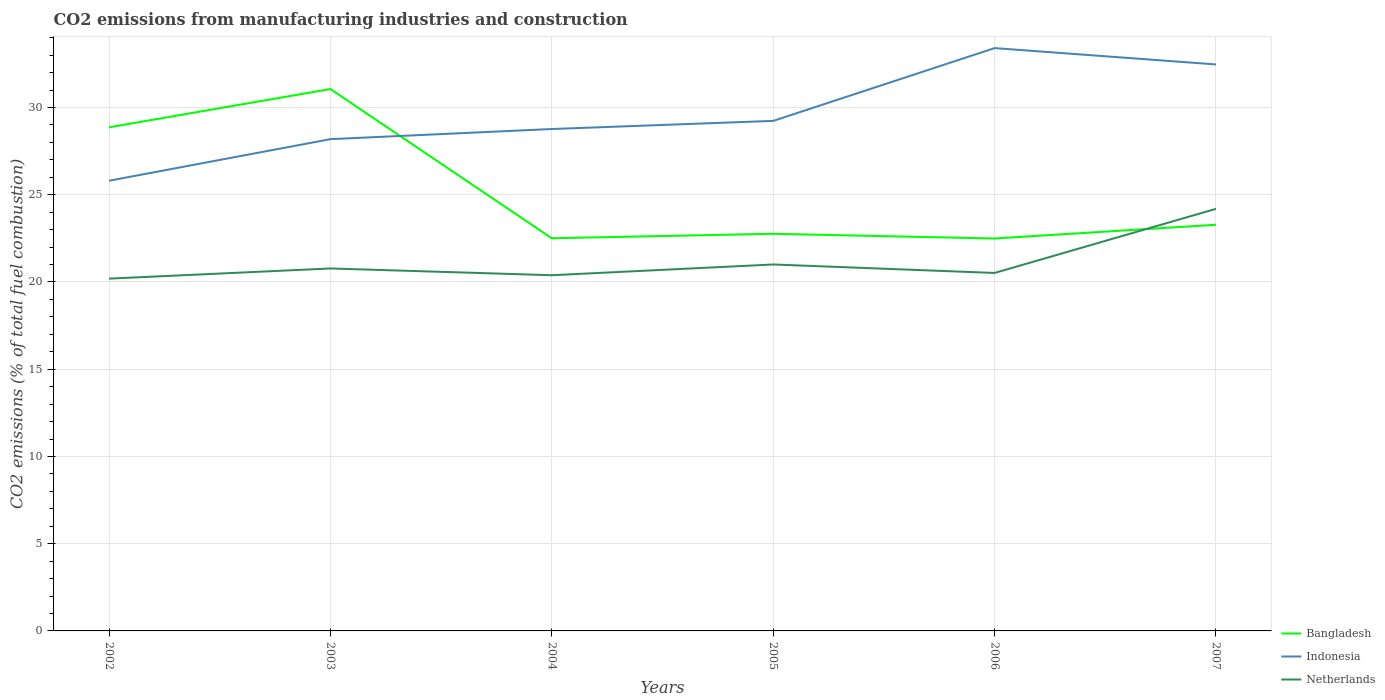Does the line corresponding to Indonesia intersect with the line corresponding to Bangladesh?
Provide a succinct answer. Yes. Is the number of lines equal to the number of legend labels?
Provide a short and direct response. Yes. Across all years, what is the maximum amount of CO2 emitted in Bangladesh?
Your answer should be compact. 22.49. What is the total amount of CO2 emitted in Bangladesh in the graph?
Provide a succinct answer. 6.36. What is the difference between the highest and the second highest amount of CO2 emitted in Bangladesh?
Your answer should be very brief. 8.57. What is the difference between the highest and the lowest amount of CO2 emitted in Bangladesh?
Ensure brevity in your answer.  2. Is the amount of CO2 emitted in Indonesia strictly greater than the amount of CO2 emitted in Bangladesh over the years?
Your answer should be compact. No. How many lines are there?
Offer a terse response. 3. How many years are there in the graph?
Your answer should be compact. 6. What is the difference between two consecutive major ticks on the Y-axis?
Make the answer very short. 5. Does the graph contain any zero values?
Keep it short and to the point. No. Does the graph contain grids?
Offer a very short reply. Yes. How many legend labels are there?
Your answer should be compact. 3. What is the title of the graph?
Ensure brevity in your answer.  CO2 emissions from manufacturing industries and construction. Does "West Bank and Gaza" appear as one of the legend labels in the graph?
Ensure brevity in your answer.  No. What is the label or title of the Y-axis?
Provide a succinct answer. CO2 emissions (% of total fuel combustion). What is the CO2 emissions (% of total fuel combustion) in Bangladesh in 2002?
Offer a very short reply. 28.87. What is the CO2 emissions (% of total fuel combustion) in Indonesia in 2002?
Your answer should be very brief. 25.8. What is the CO2 emissions (% of total fuel combustion) in Netherlands in 2002?
Your response must be concise. 20.19. What is the CO2 emissions (% of total fuel combustion) in Bangladesh in 2003?
Your answer should be compact. 31.06. What is the CO2 emissions (% of total fuel combustion) of Indonesia in 2003?
Provide a succinct answer. 28.19. What is the CO2 emissions (% of total fuel combustion) of Netherlands in 2003?
Keep it short and to the point. 20.78. What is the CO2 emissions (% of total fuel combustion) in Bangladesh in 2004?
Provide a succinct answer. 22.51. What is the CO2 emissions (% of total fuel combustion) in Indonesia in 2004?
Offer a terse response. 28.77. What is the CO2 emissions (% of total fuel combustion) of Netherlands in 2004?
Make the answer very short. 20.39. What is the CO2 emissions (% of total fuel combustion) of Bangladesh in 2005?
Offer a very short reply. 22.76. What is the CO2 emissions (% of total fuel combustion) in Indonesia in 2005?
Offer a very short reply. 29.23. What is the CO2 emissions (% of total fuel combustion) in Netherlands in 2005?
Provide a short and direct response. 21. What is the CO2 emissions (% of total fuel combustion) in Bangladesh in 2006?
Your answer should be compact. 22.49. What is the CO2 emissions (% of total fuel combustion) in Indonesia in 2006?
Give a very brief answer. 33.41. What is the CO2 emissions (% of total fuel combustion) in Netherlands in 2006?
Offer a terse response. 20.52. What is the CO2 emissions (% of total fuel combustion) of Bangladesh in 2007?
Keep it short and to the point. 23.28. What is the CO2 emissions (% of total fuel combustion) in Indonesia in 2007?
Offer a very short reply. 32.47. What is the CO2 emissions (% of total fuel combustion) of Netherlands in 2007?
Ensure brevity in your answer.  24.19. Across all years, what is the maximum CO2 emissions (% of total fuel combustion) in Bangladesh?
Offer a very short reply. 31.06. Across all years, what is the maximum CO2 emissions (% of total fuel combustion) of Indonesia?
Offer a very short reply. 33.41. Across all years, what is the maximum CO2 emissions (% of total fuel combustion) in Netherlands?
Make the answer very short. 24.19. Across all years, what is the minimum CO2 emissions (% of total fuel combustion) of Bangladesh?
Offer a very short reply. 22.49. Across all years, what is the minimum CO2 emissions (% of total fuel combustion) of Indonesia?
Offer a terse response. 25.8. Across all years, what is the minimum CO2 emissions (% of total fuel combustion) of Netherlands?
Your answer should be compact. 20.19. What is the total CO2 emissions (% of total fuel combustion) in Bangladesh in the graph?
Make the answer very short. 150.97. What is the total CO2 emissions (% of total fuel combustion) in Indonesia in the graph?
Provide a succinct answer. 177.87. What is the total CO2 emissions (% of total fuel combustion) of Netherlands in the graph?
Offer a terse response. 127.07. What is the difference between the CO2 emissions (% of total fuel combustion) of Bangladesh in 2002 and that in 2003?
Offer a terse response. -2.19. What is the difference between the CO2 emissions (% of total fuel combustion) of Indonesia in 2002 and that in 2003?
Your answer should be compact. -2.38. What is the difference between the CO2 emissions (% of total fuel combustion) in Netherlands in 2002 and that in 2003?
Your answer should be compact. -0.58. What is the difference between the CO2 emissions (% of total fuel combustion) of Bangladesh in 2002 and that in 2004?
Keep it short and to the point. 6.36. What is the difference between the CO2 emissions (% of total fuel combustion) of Indonesia in 2002 and that in 2004?
Offer a terse response. -2.96. What is the difference between the CO2 emissions (% of total fuel combustion) in Netherlands in 2002 and that in 2004?
Provide a short and direct response. -0.2. What is the difference between the CO2 emissions (% of total fuel combustion) of Bangladesh in 2002 and that in 2005?
Keep it short and to the point. 6.1. What is the difference between the CO2 emissions (% of total fuel combustion) in Indonesia in 2002 and that in 2005?
Provide a succinct answer. -3.43. What is the difference between the CO2 emissions (% of total fuel combustion) of Netherlands in 2002 and that in 2005?
Provide a short and direct response. -0.81. What is the difference between the CO2 emissions (% of total fuel combustion) in Bangladesh in 2002 and that in 2006?
Provide a succinct answer. 6.37. What is the difference between the CO2 emissions (% of total fuel combustion) in Indonesia in 2002 and that in 2006?
Give a very brief answer. -7.6. What is the difference between the CO2 emissions (% of total fuel combustion) of Netherlands in 2002 and that in 2006?
Ensure brevity in your answer.  -0.33. What is the difference between the CO2 emissions (% of total fuel combustion) in Bangladesh in 2002 and that in 2007?
Offer a very short reply. 5.58. What is the difference between the CO2 emissions (% of total fuel combustion) in Indonesia in 2002 and that in 2007?
Provide a succinct answer. -6.67. What is the difference between the CO2 emissions (% of total fuel combustion) in Netherlands in 2002 and that in 2007?
Your answer should be very brief. -4. What is the difference between the CO2 emissions (% of total fuel combustion) in Bangladesh in 2003 and that in 2004?
Offer a terse response. 8.55. What is the difference between the CO2 emissions (% of total fuel combustion) in Indonesia in 2003 and that in 2004?
Ensure brevity in your answer.  -0.58. What is the difference between the CO2 emissions (% of total fuel combustion) in Netherlands in 2003 and that in 2004?
Make the answer very short. 0.39. What is the difference between the CO2 emissions (% of total fuel combustion) of Bangladesh in 2003 and that in 2005?
Your answer should be very brief. 8.3. What is the difference between the CO2 emissions (% of total fuel combustion) in Indonesia in 2003 and that in 2005?
Keep it short and to the point. -1.05. What is the difference between the CO2 emissions (% of total fuel combustion) of Netherlands in 2003 and that in 2005?
Make the answer very short. -0.23. What is the difference between the CO2 emissions (% of total fuel combustion) of Bangladesh in 2003 and that in 2006?
Your response must be concise. 8.57. What is the difference between the CO2 emissions (% of total fuel combustion) in Indonesia in 2003 and that in 2006?
Ensure brevity in your answer.  -5.22. What is the difference between the CO2 emissions (% of total fuel combustion) of Netherlands in 2003 and that in 2006?
Offer a very short reply. 0.26. What is the difference between the CO2 emissions (% of total fuel combustion) in Bangladesh in 2003 and that in 2007?
Your response must be concise. 7.78. What is the difference between the CO2 emissions (% of total fuel combustion) of Indonesia in 2003 and that in 2007?
Your answer should be compact. -4.28. What is the difference between the CO2 emissions (% of total fuel combustion) of Netherlands in 2003 and that in 2007?
Provide a short and direct response. -3.42. What is the difference between the CO2 emissions (% of total fuel combustion) of Bangladesh in 2004 and that in 2005?
Make the answer very short. -0.26. What is the difference between the CO2 emissions (% of total fuel combustion) of Indonesia in 2004 and that in 2005?
Give a very brief answer. -0.47. What is the difference between the CO2 emissions (% of total fuel combustion) in Netherlands in 2004 and that in 2005?
Provide a succinct answer. -0.62. What is the difference between the CO2 emissions (% of total fuel combustion) of Bangladesh in 2004 and that in 2006?
Ensure brevity in your answer.  0.01. What is the difference between the CO2 emissions (% of total fuel combustion) of Indonesia in 2004 and that in 2006?
Your response must be concise. -4.64. What is the difference between the CO2 emissions (% of total fuel combustion) in Netherlands in 2004 and that in 2006?
Your response must be concise. -0.13. What is the difference between the CO2 emissions (% of total fuel combustion) of Bangladesh in 2004 and that in 2007?
Offer a terse response. -0.77. What is the difference between the CO2 emissions (% of total fuel combustion) of Indonesia in 2004 and that in 2007?
Make the answer very short. -3.7. What is the difference between the CO2 emissions (% of total fuel combustion) of Netherlands in 2004 and that in 2007?
Provide a short and direct response. -3.81. What is the difference between the CO2 emissions (% of total fuel combustion) of Bangladesh in 2005 and that in 2006?
Your answer should be compact. 0.27. What is the difference between the CO2 emissions (% of total fuel combustion) of Indonesia in 2005 and that in 2006?
Offer a terse response. -4.17. What is the difference between the CO2 emissions (% of total fuel combustion) of Netherlands in 2005 and that in 2006?
Your answer should be compact. 0.49. What is the difference between the CO2 emissions (% of total fuel combustion) in Bangladesh in 2005 and that in 2007?
Your answer should be compact. -0.52. What is the difference between the CO2 emissions (% of total fuel combustion) of Indonesia in 2005 and that in 2007?
Your answer should be compact. -3.24. What is the difference between the CO2 emissions (% of total fuel combustion) in Netherlands in 2005 and that in 2007?
Ensure brevity in your answer.  -3.19. What is the difference between the CO2 emissions (% of total fuel combustion) in Bangladesh in 2006 and that in 2007?
Provide a short and direct response. -0.79. What is the difference between the CO2 emissions (% of total fuel combustion) of Indonesia in 2006 and that in 2007?
Provide a succinct answer. 0.94. What is the difference between the CO2 emissions (% of total fuel combustion) of Netherlands in 2006 and that in 2007?
Give a very brief answer. -3.68. What is the difference between the CO2 emissions (% of total fuel combustion) of Bangladesh in 2002 and the CO2 emissions (% of total fuel combustion) of Indonesia in 2003?
Offer a very short reply. 0.68. What is the difference between the CO2 emissions (% of total fuel combustion) in Bangladesh in 2002 and the CO2 emissions (% of total fuel combustion) in Netherlands in 2003?
Make the answer very short. 8.09. What is the difference between the CO2 emissions (% of total fuel combustion) in Indonesia in 2002 and the CO2 emissions (% of total fuel combustion) in Netherlands in 2003?
Ensure brevity in your answer.  5.03. What is the difference between the CO2 emissions (% of total fuel combustion) in Bangladesh in 2002 and the CO2 emissions (% of total fuel combustion) in Indonesia in 2004?
Your answer should be compact. 0.1. What is the difference between the CO2 emissions (% of total fuel combustion) in Bangladesh in 2002 and the CO2 emissions (% of total fuel combustion) in Netherlands in 2004?
Your answer should be very brief. 8.48. What is the difference between the CO2 emissions (% of total fuel combustion) of Indonesia in 2002 and the CO2 emissions (% of total fuel combustion) of Netherlands in 2004?
Your answer should be very brief. 5.42. What is the difference between the CO2 emissions (% of total fuel combustion) in Bangladesh in 2002 and the CO2 emissions (% of total fuel combustion) in Indonesia in 2005?
Give a very brief answer. -0.37. What is the difference between the CO2 emissions (% of total fuel combustion) in Bangladesh in 2002 and the CO2 emissions (% of total fuel combustion) in Netherlands in 2005?
Ensure brevity in your answer.  7.86. What is the difference between the CO2 emissions (% of total fuel combustion) of Indonesia in 2002 and the CO2 emissions (% of total fuel combustion) of Netherlands in 2005?
Your answer should be compact. 4.8. What is the difference between the CO2 emissions (% of total fuel combustion) in Bangladesh in 2002 and the CO2 emissions (% of total fuel combustion) in Indonesia in 2006?
Your answer should be very brief. -4.54. What is the difference between the CO2 emissions (% of total fuel combustion) in Bangladesh in 2002 and the CO2 emissions (% of total fuel combustion) in Netherlands in 2006?
Ensure brevity in your answer.  8.35. What is the difference between the CO2 emissions (% of total fuel combustion) in Indonesia in 2002 and the CO2 emissions (% of total fuel combustion) in Netherlands in 2006?
Your answer should be very brief. 5.29. What is the difference between the CO2 emissions (% of total fuel combustion) in Bangladesh in 2002 and the CO2 emissions (% of total fuel combustion) in Indonesia in 2007?
Your answer should be compact. -3.6. What is the difference between the CO2 emissions (% of total fuel combustion) in Bangladesh in 2002 and the CO2 emissions (% of total fuel combustion) in Netherlands in 2007?
Give a very brief answer. 4.67. What is the difference between the CO2 emissions (% of total fuel combustion) in Indonesia in 2002 and the CO2 emissions (% of total fuel combustion) in Netherlands in 2007?
Provide a succinct answer. 1.61. What is the difference between the CO2 emissions (% of total fuel combustion) of Bangladesh in 2003 and the CO2 emissions (% of total fuel combustion) of Indonesia in 2004?
Offer a terse response. 2.29. What is the difference between the CO2 emissions (% of total fuel combustion) of Bangladesh in 2003 and the CO2 emissions (% of total fuel combustion) of Netherlands in 2004?
Give a very brief answer. 10.67. What is the difference between the CO2 emissions (% of total fuel combustion) of Indonesia in 2003 and the CO2 emissions (% of total fuel combustion) of Netherlands in 2004?
Make the answer very short. 7.8. What is the difference between the CO2 emissions (% of total fuel combustion) in Bangladesh in 2003 and the CO2 emissions (% of total fuel combustion) in Indonesia in 2005?
Make the answer very short. 1.83. What is the difference between the CO2 emissions (% of total fuel combustion) in Bangladesh in 2003 and the CO2 emissions (% of total fuel combustion) in Netherlands in 2005?
Provide a succinct answer. 10.06. What is the difference between the CO2 emissions (% of total fuel combustion) of Indonesia in 2003 and the CO2 emissions (% of total fuel combustion) of Netherlands in 2005?
Provide a short and direct response. 7.18. What is the difference between the CO2 emissions (% of total fuel combustion) in Bangladesh in 2003 and the CO2 emissions (% of total fuel combustion) in Indonesia in 2006?
Ensure brevity in your answer.  -2.35. What is the difference between the CO2 emissions (% of total fuel combustion) in Bangladesh in 2003 and the CO2 emissions (% of total fuel combustion) in Netherlands in 2006?
Keep it short and to the point. 10.54. What is the difference between the CO2 emissions (% of total fuel combustion) of Indonesia in 2003 and the CO2 emissions (% of total fuel combustion) of Netherlands in 2006?
Offer a terse response. 7.67. What is the difference between the CO2 emissions (% of total fuel combustion) in Bangladesh in 2003 and the CO2 emissions (% of total fuel combustion) in Indonesia in 2007?
Your answer should be very brief. -1.41. What is the difference between the CO2 emissions (% of total fuel combustion) in Bangladesh in 2003 and the CO2 emissions (% of total fuel combustion) in Netherlands in 2007?
Offer a very short reply. 6.87. What is the difference between the CO2 emissions (% of total fuel combustion) in Indonesia in 2003 and the CO2 emissions (% of total fuel combustion) in Netherlands in 2007?
Give a very brief answer. 3.99. What is the difference between the CO2 emissions (% of total fuel combustion) in Bangladesh in 2004 and the CO2 emissions (% of total fuel combustion) in Indonesia in 2005?
Keep it short and to the point. -6.73. What is the difference between the CO2 emissions (% of total fuel combustion) of Bangladesh in 2004 and the CO2 emissions (% of total fuel combustion) of Netherlands in 2005?
Offer a very short reply. 1.5. What is the difference between the CO2 emissions (% of total fuel combustion) in Indonesia in 2004 and the CO2 emissions (% of total fuel combustion) in Netherlands in 2005?
Your answer should be compact. 7.76. What is the difference between the CO2 emissions (% of total fuel combustion) in Bangladesh in 2004 and the CO2 emissions (% of total fuel combustion) in Indonesia in 2006?
Provide a short and direct response. -10.9. What is the difference between the CO2 emissions (% of total fuel combustion) of Bangladesh in 2004 and the CO2 emissions (% of total fuel combustion) of Netherlands in 2006?
Make the answer very short. 1.99. What is the difference between the CO2 emissions (% of total fuel combustion) of Indonesia in 2004 and the CO2 emissions (% of total fuel combustion) of Netherlands in 2006?
Your answer should be very brief. 8.25. What is the difference between the CO2 emissions (% of total fuel combustion) of Bangladesh in 2004 and the CO2 emissions (% of total fuel combustion) of Indonesia in 2007?
Your answer should be very brief. -9.96. What is the difference between the CO2 emissions (% of total fuel combustion) of Bangladesh in 2004 and the CO2 emissions (% of total fuel combustion) of Netherlands in 2007?
Keep it short and to the point. -1.69. What is the difference between the CO2 emissions (% of total fuel combustion) in Indonesia in 2004 and the CO2 emissions (% of total fuel combustion) in Netherlands in 2007?
Your answer should be very brief. 4.57. What is the difference between the CO2 emissions (% of total fuel combustion) in Bangladesh in 2005 and the CO2 emissions (% of total fuel combustion) in Indonesia in 2006?
Provide a short and direct response. -10.64. What is the difference between the CO2 emissions (% of total fuel combustion) of Bangladesh in 2005 and the CO2 emissions (% of total fuel combustion) of Netherlands in 2006?
Keep it short and to the point. 2.25. What is the difference between the CO2 emissions (% of total fuel combustion) in Indonesia in 2005 and the CO2 emissions (% of total fuel combustion) in Netherlands in 2006?
Ensure brevity in your answer.  8.72. What is the difference between the CO2 emissions (% of total fuel combustion) of Bangladesh in 2005 and the CO2 emissions (% of total fuel combustion) of Indonesia in 2007?
Provide a succinct answer. -9.71. What is the difference between the CO2 emissions (% of total fuel combustion) in Bangladesh in 2005 and the CO2 emissions (% of total fuel combustion) in Netherlands in 2007?
Keep it short and to the point. -1.43. What is the difference between the CO2 emissions (% of total fuel combustion) of Indonesia in 2005 and the CO2 emissions (% of total fuel combustion) of Netherlands in 2007?
Provide a short and direct response. 5.04. What is the difference between the CO2 emissions (% of total fuel combustion) in Bangladesh in 2006 and the CO2 emissions (% of total fuel combustion) in Indonesia in 2007?
Your answer should be very brief. -9.98. What is the difference between the CO2 emissions (% of total fuel combustion) of Bangladesh in 2006 and the CO2 emissions (% of total fuel combustion) of Netherlands in 2007?
Your answer should be very brief. -1.7. What is the difference between the CO2 emissions (% of total fuel combustion) of Indonesia in 2006 and the CO2 emissions (% of total fuel combustion) of Netherlands in 2007?
Your answer should be very brief. 9.21. What is the average CO2 emissions (% of total fuel combustion) in Bangladesh per year?
Your response must be concise. 25.16. What is the average CO2 emissions (% of total fuel combustion) of Indonesia per year?
Keep it short and to the point. 29.64. What is the average CO2 emissions (% of total fuel combustion) in Netherlands per year?
Offer a terse response. 21.18. In the year 2002, what is the difference between the CO2 emissions (% of total fuel combustion) of Bangladesh and CO2 emissions (% of total fuel combustion) of Indonesia?
Offer a very short reply. 3.06. In the year 2002, what is the difference between the CO2 emissions (% of total fuel combustion) in Bangladesh and CO2 emissions (% of total fuel combustion) in Netherlands?
Keep it short and to the point. 8.67. In the year 2002, what is the difference between the CO2 emissions (% of total fuel combustion) in Indonesia and CO2 emissions (% of total fuel combustion) in Netherlands?
Keep it short and to the point. 5.61. In the year 2003, what is the difference between the CO2 emissions (% of total fuel combustion) of Bangladesh and CO2 emissions (% of total fuel combustion) of Indonesia?
Your answer should be compact. 2.87. In the year 2003, what is the difference between the CO2 emissions (% of total fuel combustion) in Bangladesh and CO2 emissions (% of total fuel combustion) in Netherlands?
Keep it short and to the point. 10.28. In the year 2003, what is the difference between the CO2 emissions (% of total fuel combustion) of Indonesia and CO2 emissions (% of total fuel combustion) of Netherlands?
Provide a short and direct response. 7.41. In the year 2004, what is the difference between the CO2 emissions (% of total fuel combustion) in Bangladesh and CO2 emissions (% of total fuel combustion) in Indonesia?
Ensure brevity in your answer.  -6.26. In the year 2004, what is the difference between the CO2 emissions (% of total fuel combustion) in Bangladesh and CO2 emissions (% of total fuel combustion) in Netherlands?
Your answer should be compact. 2.12. In the year 2004, what is the difference between the CO2 emissions (% of total fuel combustion) in Indonesia and CO2 emissions (% of total fuel combustion) in Netherlands?
Your answer should be very brief. 8.38. In the year 2005, what is the difference between the CO2 emissions (% of total fuel combustion) of Bangladesh and CO2 emissions (% of total fuel combustion) of Indonesia?
Offer a very short reply. -6.47. In the year 2005, what is the difference between the CO2 emissions (% of total fuel combustion) of Bangladesh and CO2 emissions (% of total fuel combustion) of Netherlands?
Provide a short and direct response. 1.76. In the year 2005, what is the difference between the CO2 emissions (% of total fuel combustion) of Indonesia and CO2 emissions (% of total fuel combustion) of Netherlands?
Offer a very short reply. 8.23. In the year 2006, what is the difference between the CO2 emissions (% of total fuel combustion) of Bangladesh and CO2 emissions (% of total fuel combustion) of Indonesia?
Offer a terse response. -10.91. In the year 2006, what is the difference between the CO2 emissions (% of total fuel combustion) of Bangladesh and CO2 emissions (% of total fuel combustion) of Netherlands?
Give a very brief answer. 1.97. In the year 2006, what is the difference between the CO2 emissions (% of total fuel combustion) of Indonesia and CO2 emissions (% of total fuel combustion) of Netherlands?
Give a very brief answer. 12.89. In the year 2007, what is the difference between the CO2 emissions (% of total fuel combustion) of Bangladesh and CO2 emissions (% of total fuel combustion) of Indonesia?
Provide a succinct answer. -9.19. In the year 2007, what is the difference between the CO2 emissions (% of total fuel combustion) in Bangladesh and CO2 emissions (% of total fuel combustion) in Netherlands?
Your answer should be very brief. -0.91. In the year 2007, what is the difference between the CO2 emissions (% of total fuel combustion) of Indonesia and CO2 emissions (% of total fuel combustion) of Netherlands?
Provide a short and direct response. 8.28. What is the ratio of the CO2 emissions (% of total fuel combustion) in Bangladesh in 2002 to that in 2003?
Your answer should be very brief. 0.93. What is the ratio of the CO2 emissions (% of total fuel combustion) in Indonesia in 2002 to that in 2003?
Keep it short and to the point. 0.92. What is the ratio of the CO2 emissions (% of total fuel combustion) of Netherlands in 2002 to that in 2003?
Keep it short and to the point. 0.97. What is the ratio of the CO2 emissions (% of total fuel combustion) of Bangladesh in 2002 to that in 2004?
Ensure brevity in your answer.  1.28. What is the ratio of the CO2 emissions (% of total fuel combustion) of Indonesia in 2002 to that in 2004?
Keep it short and to the point. 0.9. What is the ratio of the CO2 emissions (% of total fuel combustion) of Netherlands in 2002 to that in 2004?
Offer a terse response. 0.99. What is the ratio of the CO2 emissions (% of total fuel combustion) of Bangladesh in 2002 to that in 2005?
Your response must be concise. 1.27. What is the ratio of the CO2 emissions (% of total fuel combustion) in Indonesia in 2002 to that in 2005?
Make the answer very short. 0.88. What is the ratio of the CO2 emissions (% of total fuel combustion) of Netherlands in 2002 to that in 2005?
Offer a terse response. 0.96. What is the ratio of the CO2 emissions (% of total fuel combustion) of Bangladesh in 2002 to that in 2006?
Make the answer very short. 1.28. What is the ratio of the CO2 emissions (% of total fuel combustion) of Indonesia in 2002 to that in 2006?
Ensure brevity in your answer.  0.77. What is the ratio of the CO2 emissions (% of total fuel combustion) in Netherlands in 2002 to that in 2006?
Ensure brevity in your answer.  0.98. What is the ratio of the CO2 emissions (% of total fuel combustion) of Bangladesh in 2002 to that in 2007?
Your response must be concise. 1.24. What is the ratio of the CO2 emissions (% of total fuel combustion) of Indonesia in 2002 to that in 2007?
Give a very brief answer. 0.79. What is the ratio of the CO2 emissions (% of total fuel combustion) in Netherlands in 2002 to that in 2007?
Make the answer very short. 0.83. What is the ratio of the CO2 emissions (% of total fuel combustion) of Bangladesh in 2003 to that in 2004?
Your answer should be very brief. 1.38. What is the ratio of the CO2 emissions (% of total fuel combustion) in Indonesia in 2003 to that in 2004?
Make the answer very short. 0.98. What is the ratio of the CO2 emissions (% of total fuel combustion) of Netherlands in 2003 to that in 2004?
Your answer should be very brief. 1.02. What is the ratio of the CO2 emissions (% of total fuel combustion) in Bangladesh in 2003 to that in 2005?
Give a very brief answer. 1.36. What is the ratio of the CO2 emissions (% of total fuel combustion) in Indonesia in 2003 to that in 2005?
Provide a short and direct response. 0.96. What is the ratio of the CO2 emissions (% of total fuel combustion) of Netherlands in 2003 to that in 2005?
Give a very brief answer. 0.99. What is the ratio of the CO2 emissions (% of total fuel combustion) of Bangladesh in 2003 to that in 2006?
Provide a short and direct response. 1.38. What is the ratio of the CO2 emissions (% of total fuel combustion) of Indonesia in 2003 to that in 2006?
Offer a terse response. 0.84. What is the ratio of the CO2 emissions (% of total fuel combustion) of Netherlands in 2003 to that in 2006?
Your answer should be compact. 1.01. What is the ratio of the CO2 emissions (% of total fuel combustion) of Bangladesh in 2003 to that in 2007?
Give a very brief answer. 1.33. What is the ratio of the CO2 emissions (% of total fuel combustion) in Indonesia in 2003 to that in 2007?
Offer a terse response. 0.87. What is the ratio of the CO2 emissions (% of total fuel combustion) of Netherlands in 2003 to that in 2007?
Your answer should be very brief. 0.86. What is the ratio of the CO2 emissions (% of total fuel combustion) of Bangladesh in 2004 to that in 2005?
Offer a very short reply. 0.99. What is the ratio of the CO2 emissions (% of total fuel combustion) in Indonesia in 2004 to that in 2005?
Offer a very short reply. 0.98. What is the ratio of the CO2 emissions (% of total fuel combustion) in Netherlands in 2004 to that in 2005?
Keep it short and to the point. 0.97. What is the ratio of the CO2 emissions (% of total fuel combustion) in Bangladesh in 2004 to that in 2006?
Provide a succinct answer. 1. What is the ratio of the CO2 emissions (% of total fuel combustion) in Indonesia in 2004 to that in 2006?
Give a very brief answer. 0.86. What is the ratio of the CO2 emissions (% of total fuel combustion) of Bangladesh in 2004 to that in 2007?
Ensure brevity in your answer.  0.97. What is the ratio of the CO2 emissions (% of total fuel combustion) in Indonesia in 2004 to that in 2007?
Make the answer very short. 0.89. What is the ratio of the CO2 emissions (% of total fuel combustion) of Netherlands in 2004 to that in 2007?
Ensure brevity in your answer.  0.84. What is the ratio of the CO2 emissions (% of total fuel combustion) of Indonesia in 2005 to that in 2006?
Provide a succinct answer. 0.88. What is the ratio of the CO2 emissions (% of total fuel combustion) of Netherlands in 2005 to that in 2006?
Your answer should be compact. 1.02. What is the ratio of the CO2 emissions (% of total fuel combustion) in Bangladesh in 2005 to that in 2007?
Your answer should be very brief. 0.98. What is the ratio of the CO2 emissions (% of total fuel combustion) of Indonesia in 2005 to that in 2007?
Your response must be concise. 0.9. What is the ratio of the CO2 emissions (% of total fuel combustion) in Netherlands in 2005 to that in 2007?
Provide a short and direct response. 0.87. What is the ratio of the CO2 emissions (% of total fuel combustion) of Bangladesh in 2006 to that in 2007?
Provide a short and direct response. 0.97. What is the ratio of the CO2 emissions (% of total fuel combustion) of Indonesia in 2006 to that in 2007?
Provide a short and direct response. 1.03. What is the ratio of the CO2 emissions (% of total fuel combustion) of Netherlands in 2006 to that in 2007?
Your response must be concise. 0.85. What is the difference between the highest and the second highest CO2 emissions (% of total fuel combustion) of Bangladesh?
Provide a short and direct response. 2.19. What is the difference between the highest and the second highest CO2 emissions (% of total fuel combustion) in Indonesia?
Give a very brief answer. 0.94. What is the difference between the highest and the second highest CO2 emissions (% of total fuel combustion) of Netherlands?
Provide a succinct answer. 3.19. What is the difference between the highest and the lowest CO2 emissions (% of total fuel combustion) in Bangladesh?
Offer a very short reply. 8.57. What is the difference between the highest and the lowest CO2 emissions (% of total fuel combustion) of Indonesia?
Give a very brief answer. 7.6. What is the difference between the highest and the lowest CO2 emissions (% of total fuel combustion) of Netherlands?
Your response must be concise. 4. 